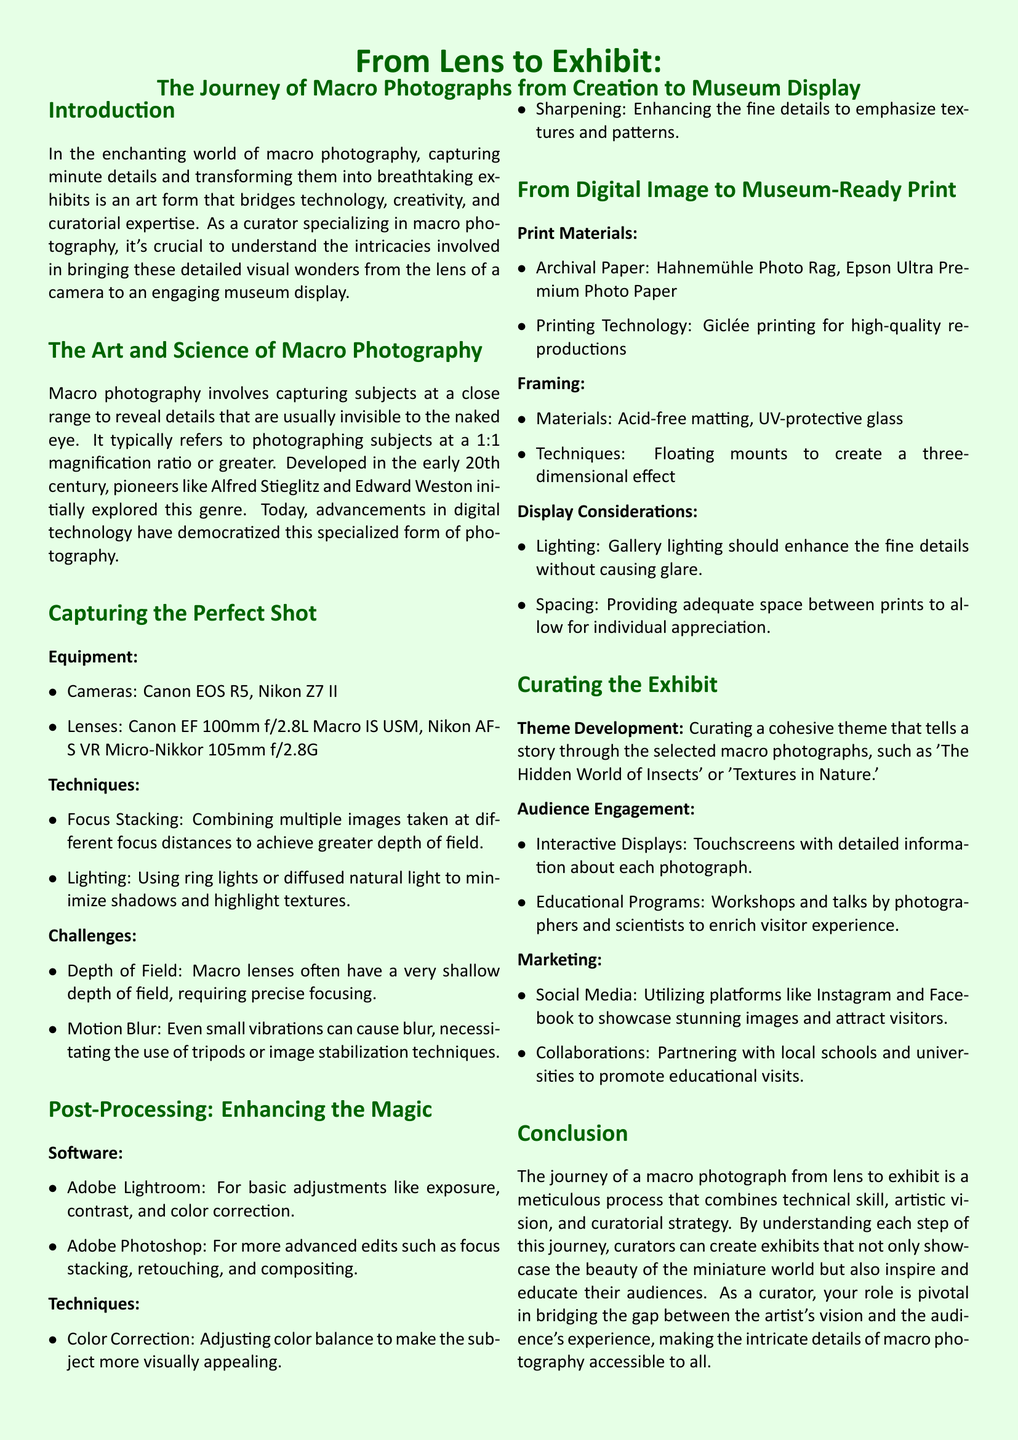What is macro photography? Macro photography involves capturing subjects at a close range to reveal details that are usually invisible to the naked eye.
Answer: Capturing subjects at a close range Who are two pioneers of macro photography? The document mentions Alfred Stieglitz and Edward Weston as early pioneers in this genre.
Answer: Alfred Stieglitz and Edward Weston What camera is listed as a recommended equipment for macro photography? The document lists the Canon EOS R5 as one of the recommended cameras.
Answer: Canon EOS R5 What is focus stacking? Focus stacking is a technique that combines multiple images taken at different focus distances to achieve greater depth of field.
Answer: Combining multiple images What is an example of an archival paper mentioned? The document mentions Hahnemühle Photo Rag as an archival paper used in printing.
Answer: Hahnemühle Photo Rag What is one of the themes suggested for curating a macro photography exhibit? The document suggests 'The Hidden World of Insects' as a cohesive theme for an exhibit.
Answer: The Hidden World of Insects What software is used for basic adjustments in post-processing? Adobe Lightroom is mentioned in the document for basic adjustments like exposure and contrast.
Answer: Adobe Lightroom What type of printing technology is highlighted for high-quality reproductions? Giclée printing is specified in the document as the printing technology for high-quality reproductions.
Answer: Giclée printing What engagement method is suggested to enhance audience interaction? The document suggests using interactive displays such as touchscreens with detailed information about each photograph.
Answer: Interactive Displays 